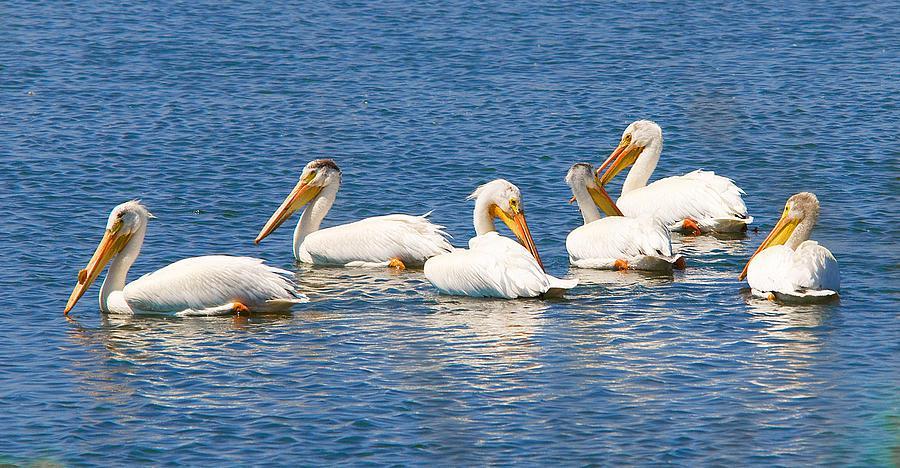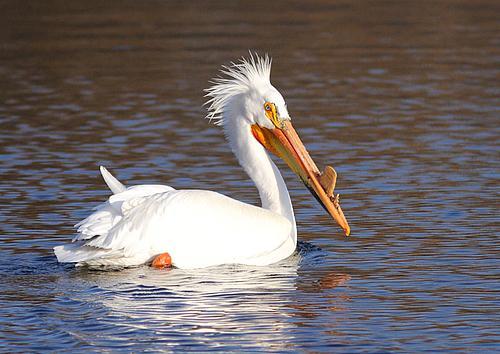The first image is the image on the left, the second image is the image on the right. Given the left and right images, does the statement "The bird in the left image that is furthest to the left is facing towards the left." hold true? Answer yes or no. Yes. The first image is the image on the left, the second image is the image on the right. For the images displayed, is the sentence "The images in each set have no more than three birds in total." factually correct? Answer yes or no. No. 